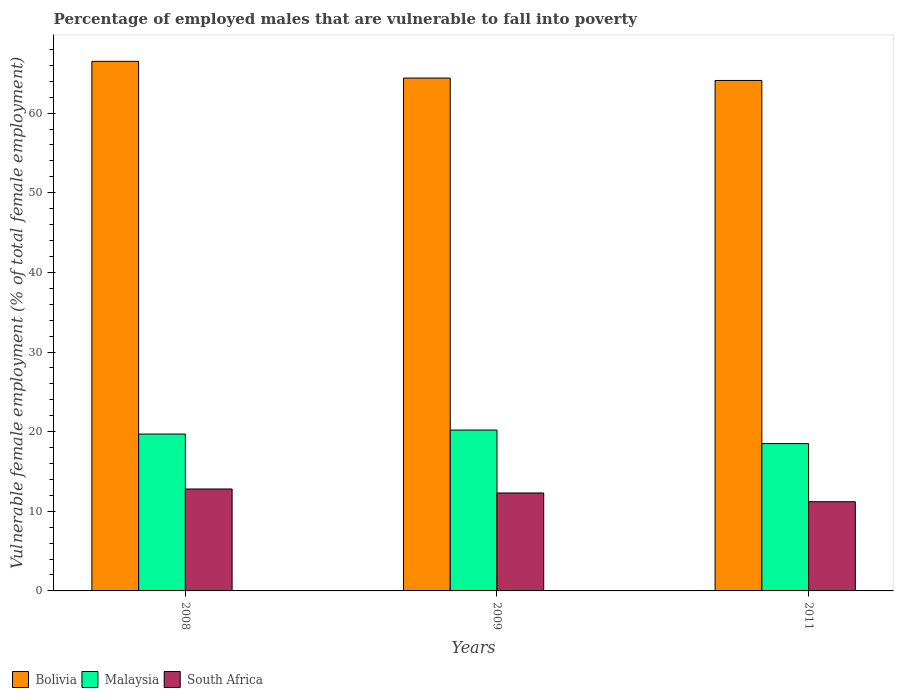How many different coloured bars are there?
Give a very brief answer. 3. Are the number of bars per tick equal to the number of legend labels?
Offer a terse response. Yes. How many bars are there on the 1st tick from the left?
Your answer should be compact. 3. How many bars are there on the 1st tick from the right?
Your answer should be very brief. 3. What is the label of the 2nd group of bars from the left?
Your response must be concise. 2009. In how many cases, is the number of bars for a given year not equal to the number of legend labels?
Ensure brevity in your answer.  0. What is the percentage of employed males who are vulnerable to fall into poverty in Bolivia in 2011?
Offer a terse response. 64.1. Across all years, what is the maximum percentage of employed males who are vulnerable to fall into poverty in Bolivia?
Offer a very short reply. 66.5. Across all years, what is the minimum percentage of employed males who are vulnerable to fall into poverty in South Africa?
Provide a short and direct response. 11.2. In which year was the percentage of employed males who are vulnerable to fall into poverty in Malaysia maximum?
Provide a short and direct response. 2009. What is the total percentage of employed males who are vulnerable to fall into poverty in Malaysia in the graph?
Your answer should be very brief. 58.4. What is the difference between the percentage of employed males who are vulnerable to fall into poverty in Malaysia in 2009 and that in 2011?
Give a very brief answer. 1.7. What is the difference between the percentage of employed males who are vulnerable to fall into poverty in Bolivia in 2008 and the percentage of employed males who are vulnerable to fall into poverty in South Africa in 2011?
Offer a very short reply. 55.3. What is the average percentage of employed males who are vulnerable to fall into poverty in Malaysia per year?
Your response must be concise. 19.47. In the year 2011, what is the difference between the percentage of employed males who are vulnerable to fall into poverty in Bolivia and percentage of employed males who are vulnerable to fall into poverty in Malaysia?
Make the answer very short. 45.6. In how many years, is the percentage of employed males who are vulnerable to fall into poverty in Bolivia greater than 24 %?
Keep it short and to the point. 3. What is the ratio of the percentage of employed males who are vulnerable to fall into poverty in Bolivia in 2008 to that in 2011?
Ensure brevity in your answer.  1.04. Is the percentage of employed males who are vulnerable to fall into poverty in South Africa in 2008 less than that in 2009?
Offer a terse response. No. What is the difference between the highest and the second highest percentage of employed males who are vulnerable to fall into poverty in Bolivia?
Your answer should be very brief. 2.1. What is the difference between the highest and the lowest percentage of employed males who are vulnerable to fall into poverty in Malaysia?
Provide a succinct answer. 1.7. In how many years, is the percentage of employed males who are vulnerable to fall into poverty in Malaysia greater than the average percentage of employed males who are vulnerable to fall into poverty in Malaysia taken over all years?
Provide a short and direct response. 2. Is the sum of the percentage of employed males who are vulnerable to fall into poverty in Malaysia in 2008 and 2009 greater than the maximum percentage of employed males who are vulnerable to fall into poverty in Bolivia across all years?
Make the answer very short. No. What does the 1st bar from the left in 2008 represents?
Offer a terse response. Bolivia. What does the 2nd bar from the right in 2011 represents?
Offer a terse response. Malaysia. How many bars are there?
Your answer should be very brief. 9. Are all the bars in the graph horizontal?
Offer a very short reply. No. Are the values on the major ticks of Y-axis written in scientific E-notation?
Give a very brief answer. No. Does the graph contain grids?
Provide a succinct answer. No. Where does the legend appear in the graph?
Your answer should be compact. Bottom left. How many legend labels are there?
Your response must be concise. 3. What is the title of the graph?
Your answer should be very brief. Percentage of employed males that are vulnerable to fall into poverty. Does "OECD members" appear as one of the legend labels in the graph?
Your answer should be very brief. No. What is the label or title of the Y-axis?
Give a very brief answer. Vulnerable female employment (% of total female employment). What is the Vulnerable female employment (% of total female employment) of Bolivia in 2008?
Provide a succinct answer. 66.5. What is the Vulnerable female employment (% of total female employment) of Malaysia in 2008?
Keep it short and to the point. 19.7. What is the Vulnerable female employment (% of total female employment) of South Africa in 2008?
Make the answer very short. 12.8. What is the Vulnerable female employment (% of total female employment) in Bolivia in 2009?
Your response must be concise. 64.4. What is the Vulnerable female employment (% of total female employment) in Malaysia in 2009?
Ensure brevity in your answer.  20.2. What is the Vulnerable female employment (% of total female employment) of South Africa in 2009?
Offer a very short reply. 12.3. What is the Vulnerable female employment (% of total female employment) in Bolivia in 2011?
Ensure brevity in your answer.  64.1. What is the Vulnerable female employment (% of total female employment) in South Africa in 2011?
Offer a very short reply. 11.2. Across all years, what is the maximum Vulnerable female employment (% of total female employment) in Bolivia?
Make the answer very short. 66.5. Across all years, what is the maximum Vulnerable female employment (% of total female employment) in Malaysia?
Give a very brief answer. 20.2. Across all years, what is the maximum Vulnerable female employment (% of total female employment) in South Africa?
Offer a very short reply. 12.8. Across all years, what is the minimum Vulnerable female employment (% of total female employment) of Bolivia?
Give a very brief answer. 64.1. Across all years, what is the minimum Vulnerable female employment (% of total female employment) in South Africa?
Your answer should be very brief. 11.2. What is the total Vulnerable female employment (% of total female employment) in Bolivia in the graph?
Give a very brief answer. 195. What is the total Vulnerable female employment (% of total female employment) in Malaysia in the graph?
Make the answer very short. 58.4. What is the total Vulnerable female employment (% of total female employment) of South Africa in the graph?
Provide a succinct answer. 36.3. What is the difference between the Vulnerable female employment (% of total female employment) of Bolivia in 2008 and that in 2009?
Your answer should be very brief. 2.1. What is the difference between the Vulnerable female employment (% of total female employment) in Malaysia in 2008 and that in 2009?
Provide a succinct answer. -0.5. What is the difference between the Vulnerable female employment (% of total female employment) in South Africa in 2008 and that in 2009?
Give a very brief answer. 0.5. What is the difference between the Vulnerable female employment (% of total female employment) of Bolivia in 2008 and that in 2011?
Provide a short and direct response. 2.4. What is the difference between the Vulnerable female employment (% of total female employment) in South Africa in 2008 and that in 2011?
Keep it short and to the point. 1.6. What is the difference between the Vulnerable female employment (% of total female employment) of Bolivia in 2009 and that in 2011?
Your response must be concise. 0.3. What is the difference between the Vulnerable female employment (% of total female employment) of Malaysia in 2009 and that in 2011?
Keep it short and to the point. 1.7. What is the difference between the Vulnerable female employment (% of total female employment) of Bolivia in 2008 and the Vulnerable female employment (% of total female employment) of Malaysia in 2009?
Your answer should be very brief. 46.3. What is the difference between the Vulnerable female employment (% of total female employment) of Bolivia in 2008 and the Vulnerable female employment (% of total female employment) of South Africa in 2009?
Your response must be concise. 54.2. What is the difference between the Vulnerable female employment (% of total female employment) of Bolivia in 2008 and the Vulnerable female employment (% of total female employment) of South Africa in 2011?
Offer a very short reply. 55.3. What is the difference between the Vulnerable female employment (% of total female employment) of Bolivia in 2009 and the Vulnerable female employment (% of total female employment) of Malaysia in 2011?
Offer a very short reply. 45.9. What is the difference between the Vulnerable female employment (% of total female employment) in Bolivia in 2009 and the Vulnerable female employment (% of total female employment) in South Africa in 2011?
Offer a terse response. 53.2. What is the average Vulnerable female employment (% of total female employment) of Bolivia per year?
Keep it short and to the point. 65. What is the average Vulnerable female employment (% of total female employment) in Malaysia per year?
Your answer should be very brief. 19.47. In the year 2008, what is the difference between the Vulnerable female employment (% of total female employment) in Bolivia and Vulnerable female employment (% of total female employment) in Malaysia?
Your answer should be compact. 46.8. In the year 2008, what is the difference between the Vulnerable female employment (% of total female employment) of Bolivia and Vulnerable female employment (% of total female employment) of South Africa?
Keep it short and to the point. 53.7. In the year 2008, what is the difference between the Vulnerable female employment (% of total female employment) in Malaysia and Vulnerable female employment (% of total female employment) in South Africa?
Ensure brevity in your answer.  6.9. In the year 2009, what is the difference between the Vulnerable female employment (% of total female employment) of Bolivia and Vulnerable female employment (% of total female employment) of Malaysia?
Offer a very short reply. 44.2. In the year 2009, what is the difference between the Vulnerable female employment (% of total female employment) in Bolivia and Vulnerable female employment (% of total female employment) in South Africa?
Your answer should be compact. 52.1. In the year 2011, what is the difference between the Vulnerable female employment (% of total female employment) in Bolivia and Vulnerable female employment (% of total female employment) in Malaysia?
Your answer should be very brief. 45.6. In the year 2011, what is the difference between the Vulnerable female employment (% of total female employment) in Bolivia and Vulnerable female employment (% of total female employment) in South Africa?
Provide a succinct answer. 52.9. What is the ratio of the Vulnerable female employment (% of total female employment) of Bolivia in 2008 to that in 2009?
Your answer should be very brief. 1.03. What is the ratio of the Vulnerable female employment (% of total female employment) of Malaysia in 2008 to that in 2009?
Provide a succinct answer. 0.98. What is the ratio of the Vulnerable female employment (% of total female employment) in South Africa in 2008 to that in 2009?
Keep it short and to the point. 1.04. What is the ratio of the Vulnerable female employment (% of total female employment) of Bolivia in 2008 to that in 2011?
Make the answer very short. 1.04. What is the ratio of the Vulnerable female employment (% of total female employment) of Malaysia in 2008 to that in 2011?
Give a very brief answer. 1.06. What is the ratio of the Vulnerable female employment (% of total female employment) of South Africa in 2008 to that in 2011?
Your answer should be compact. 1.14. What is the ratio of the Vulnerable female employment (% of total female employment) of Malaysia in 2009 to that in 2011?
Ensure brevity in your answer.  1.09. What is the ratio of the Vulnerable female employment (% of total female employment) of South Africa in 2009 to that in 2011?
Your response must be concise. 1.1. What is the difference between the highest and the lowest Vulnerable female employment (% of total female employment) in Bolivia?
Offer a terse response. 2.4. 